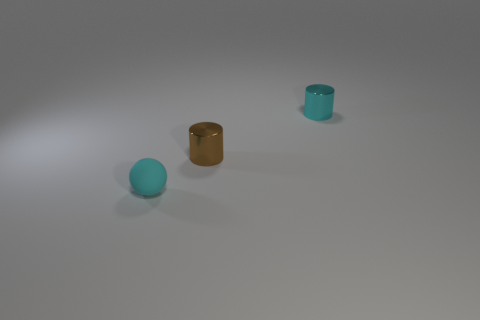There is a object that is the same color as the small rubber ball; what is its material?
Give a very brief answer. Metal. Is the number of small brown things that are in front of the tiny brown object less than the number of cyan cylinders right of the small cyan shiny object?
Keep it short and to the point. No. How many cubes are tiny brown objects or big cyan shiny objects?
Provide a succinct answer. 0. Are the small cyan thing on the right side of the small matte sphere and the object left of the brown metal object made of the same material?
Give a very brief answer. No. There is a rubber object that is the same size as the cyan metallic thing; what is its shape?
Your answer should be compact. Sphere. How many other things are the same color as the tiny ball?
Offer a terse response. 1. What number of purple objects are rubber objects or metal things?
Your response must be concise. 0. Is the shape of the cyan object behind the cyan rubber sphere the same as the small cyan thing that is in front of the brown thing?
Offer a very short reply. No. What number of other objects are the same material as the brown thing?
Offer a terse response. 1. Is there a tiny rubber thing right of the tiny metal cylinder on the right side of the tiny cylinder that is left of the cyan shiny cylinder?
Provide a succinct answer. No. 